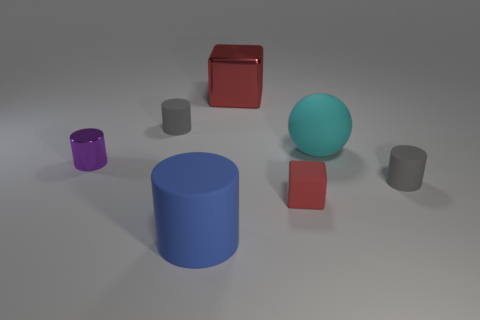What number of shiny things are cylinders or big cubes? In the image, there is one object that is a cylinder, which is the blue one in the center, and one object that is a large cube, the red one to the upper left. Therefore, there are a total of two shiny objects that fit the description of either being cylinders or big cubes. 